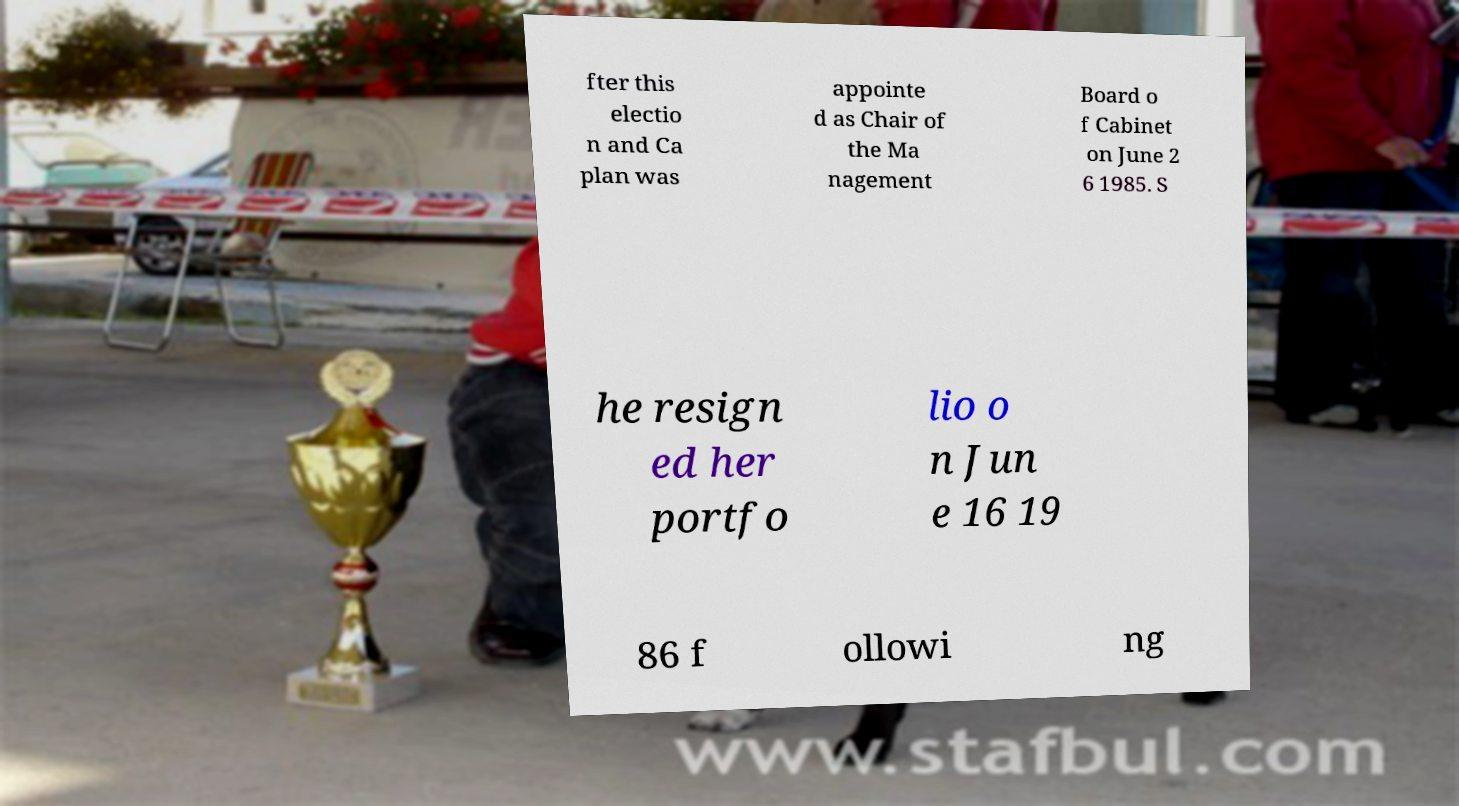Can you read and provide the text displayed in the image?This photo seems to have some interesting text. Can you extract and type it out for me? fter this electio n and Ca plan was appointe d as Chair of the Ma nagement Board o f Cabinet on June 2 6 1985. S he resign ed her portfo lio o n Jun e 16 19 86 f ollowi ng 